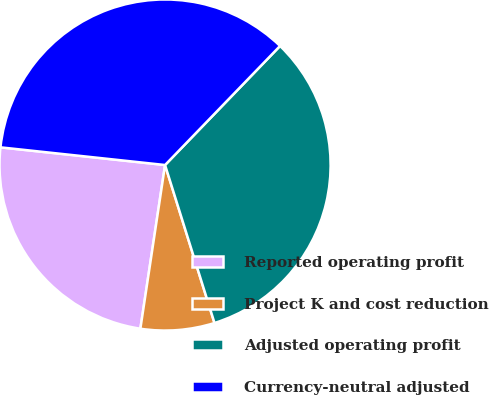Convert chart to OTSL. <chart><loc_0><loc_0><loc_500><loc_500><pie_chart><fcel>Reported operating profit<fcel>Project K and cost reduction<fcel>Adjusted operating profit<fcel>Currency-neutral adjusted<nl><fcel>24.32%<fcel>7.21%<fcel>32.95%<fcel>35.52%<nl></chart> 